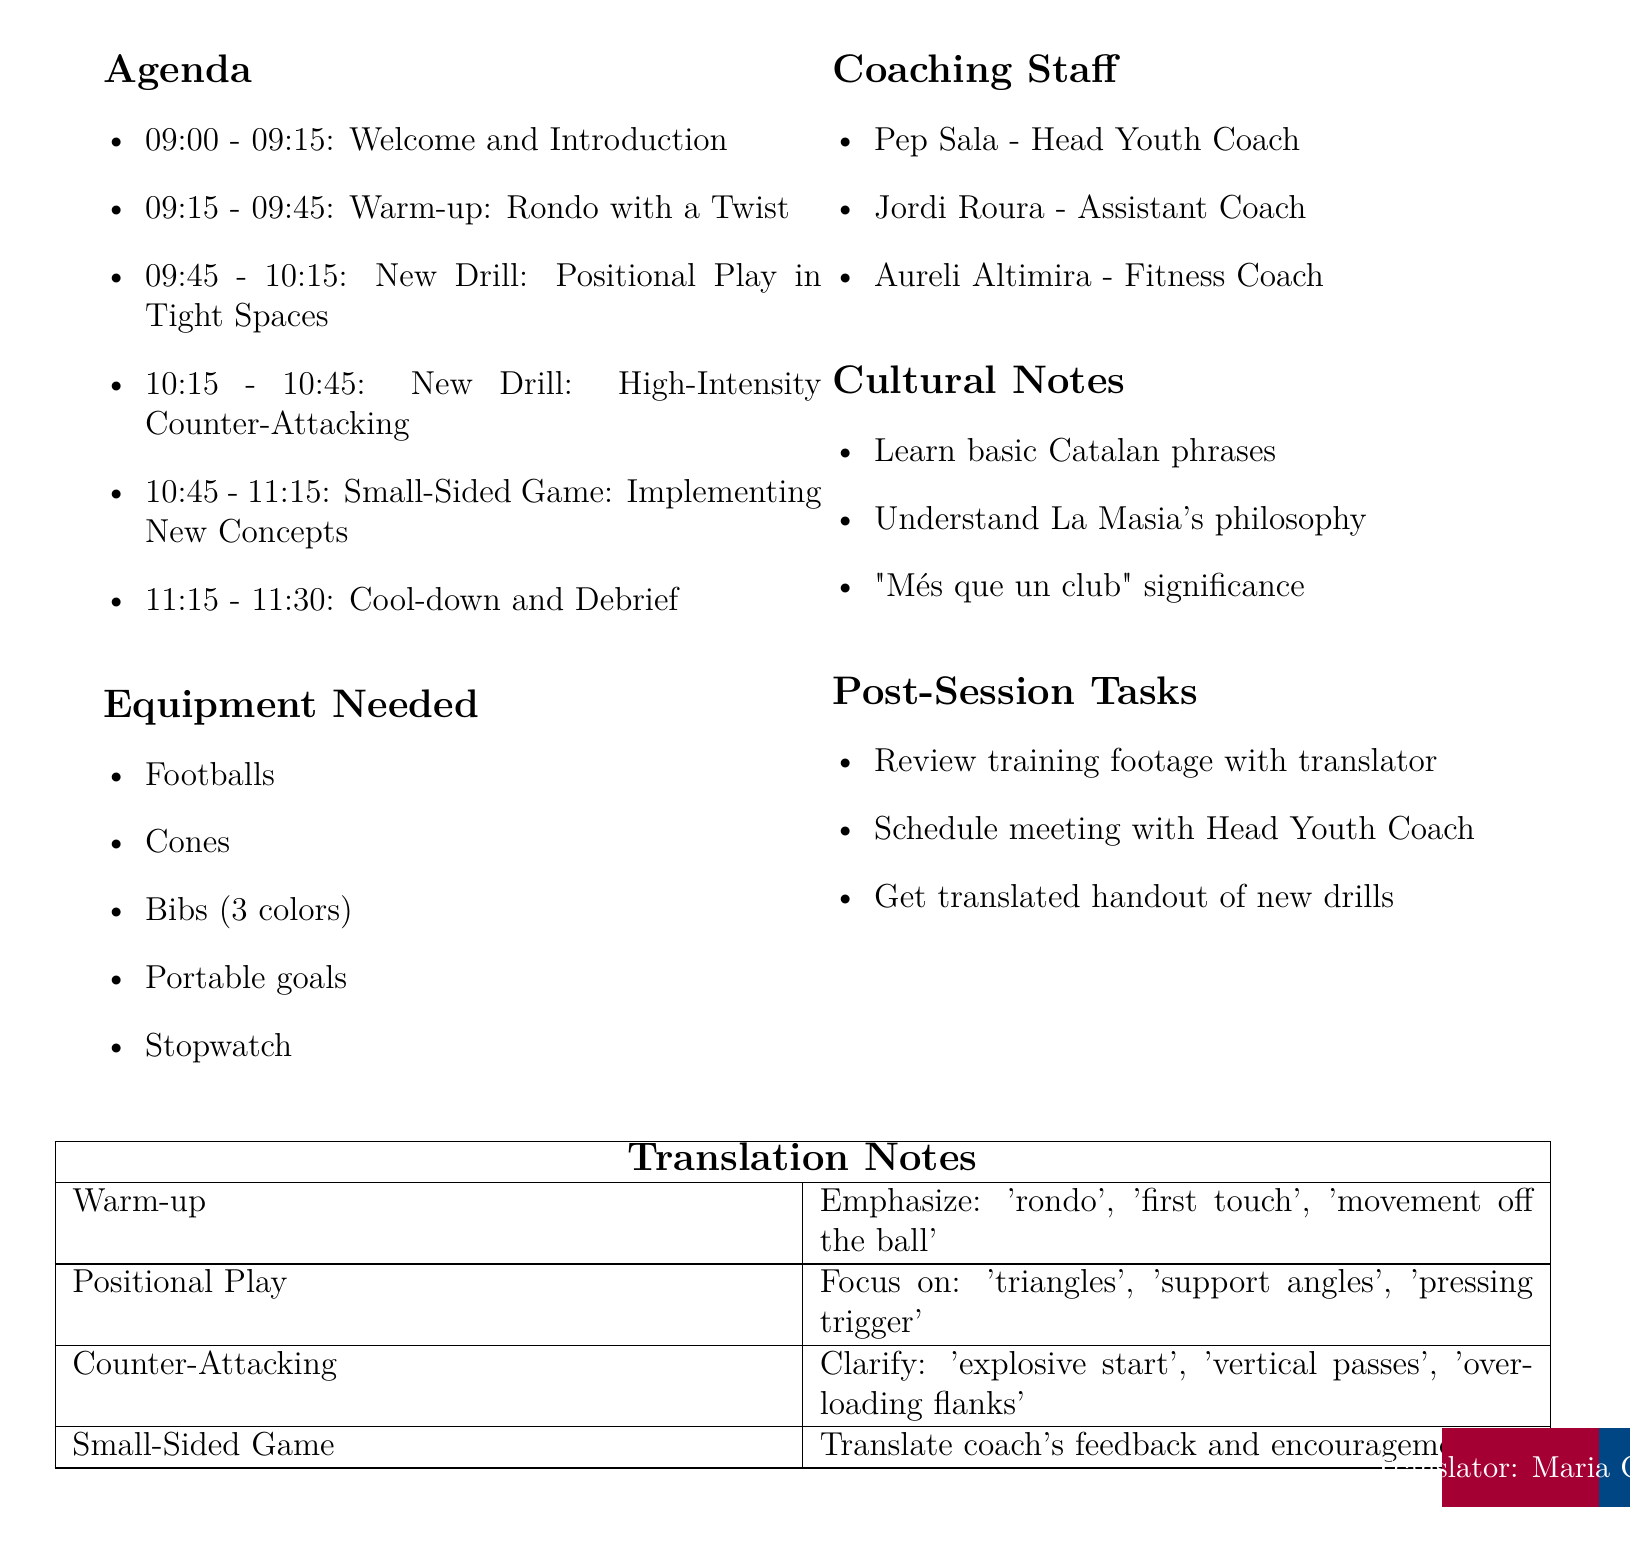What is the date of the training session? The date is specified in the agenda as the day of the training session.
Answer: 2023-05-15 What is the location of the training session? The location is clearly indicated in the agenda.
Answer: La Masia Training Ground Who is the head youth coach? The coaching staff section lists the roles and names of the coaches involved.
Answer: Pep Sala How long is the training session? The time is outlined in the agenda header, showing the start and end times.
Answer: 2 hours 30 minutes What activity is scheduled at 09:15? The agenda specifies activities in chronological order based on their scheduled times.
Answer: Warm-up: Rondo with a Twist What equipment is needed for the session? The document contains a list of required equipment for the training session.
Answer: Footballs, Cones, Bibs (3 colors), Portable goals, Stopwatch What are the cultural notes provided in the document? The cultural notes offer insights into integrating the new player into the team culture.
Answer: Learn basic Catalan phrases, Understand La Masia's philosophy, "Més que un club" significance What is one of the post-session tasks? The document includes a list of tasks to be completed after the training session.
Answer: Review training footage with translator What is the focus during the small-sided game activity? The agenda outlines the objectives for each training activity, including the small-sided game.
Answer: Implementing New Concepts 